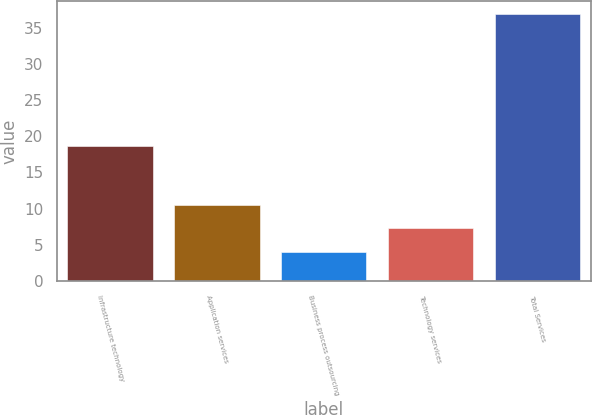Convert chart to OTSL. <chart><loc_0><loc_0><loc_500><loc_500><bar_chart><fcel>Infrastructure technology<fcel>Application services<fcel>Business process outsourcing<fcel>Technology services<fcel>Total Services<nl><fcel>18.7<fcel>10.56<fcel>4<fcel>7.28<fcel>36.8<nl></chart> 